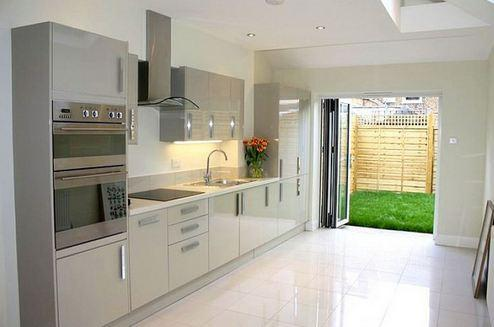What is the green object on top of the counter to the right of the sink? Please explain your reasoning. flowers. The petals are blooming from the stems. 